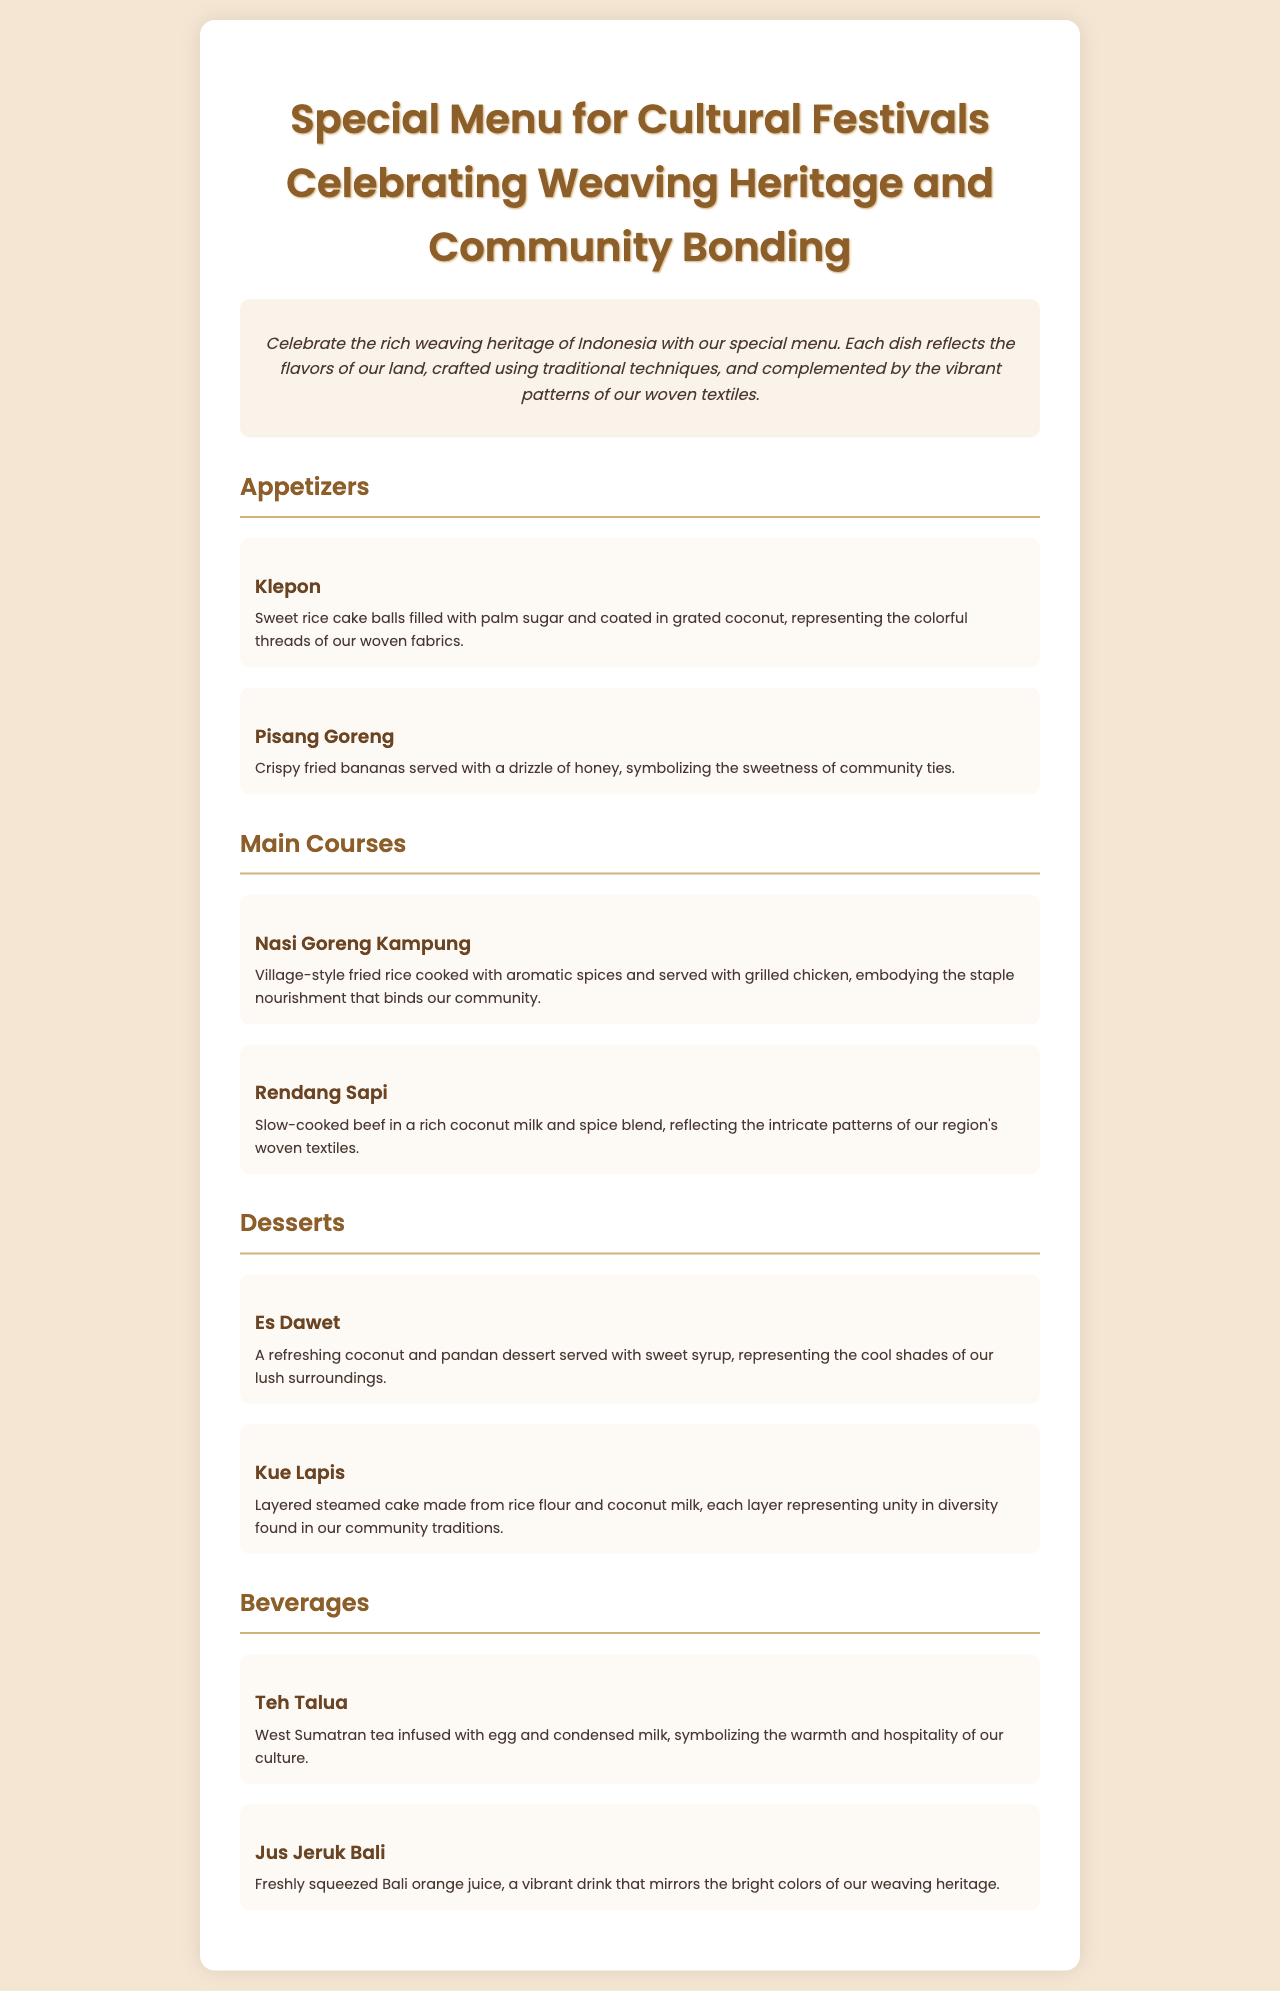what is the title of the menu? The title of the menu is prominently displayed at the top of the document, indicating the focus on cultural festivals and weaving heritage.
Answer: Special Menu for Cultural Festivals Celebrating Weaving Heritage and Community Bonding how many appetizers are listed? The document contains a section labeled "Appetizers" where two dishes are described, allowing us to ascertain the total count.
Answer: 2 what ingredient fills the Klepon? The description of Klepon directly indicates its contents.
Answer: palm sugar which main course reflects intricate patterns of woven textiles? By examining the main courses, we find a specific dish noted for embodying the attributes of woven textiles.
Answer: Rendang Sapi what is the main ingredient in Kue Lapis? The document details Kue Lapis, stating its main components, which helps identify this key ingredient.
Answer: rice flour what does Teh Talua symbolize? The description of Teh Talua provides insight into its cultural significance, indicating what it represents.
Answer: warmth and hospitality how many courses are there in total? By aggregating the individual counts of appetizers, main courses, desserts, and beverages mentioned in the menu, we can determine the total number of courses.
Answer: 4 which dessert is made from coconut and pandan? The menu specifically mentions a dessert that contains these ingredients in its description, thus identifying it directly.
Answer: Es Dawet 